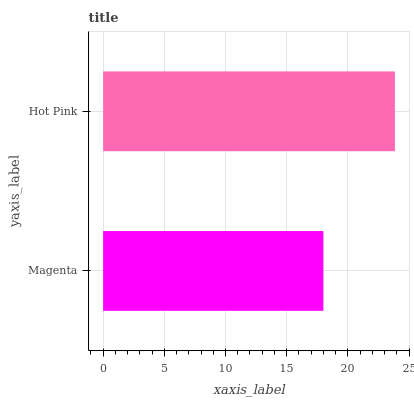Is Magenta the minimum?
Answer yes or no. Yes. Is Hot Pink the maximum?
Answer yes or no. Yes. Is Hot Pink the minimum?
Answer yes or no. No. Is Hot Pink greater than Magenta?
Answer yes or no. Yes. Is Magenta less than Hot Pink?
Answer yes or no. Yes. Is Magenta greater than Hot Pink?
Answer yes or no. No. Is Hot Pink less than Magenta?
Answer yes or no. No. Is Hot Pink the high median?
Answer yes or no. Yes. Is Magenta the low median?
Answer yes or no. Yes. Is Magenta the high median?
Answer yes or no. No. Is Hot Pink the low median?
Answer yes or no. No. 